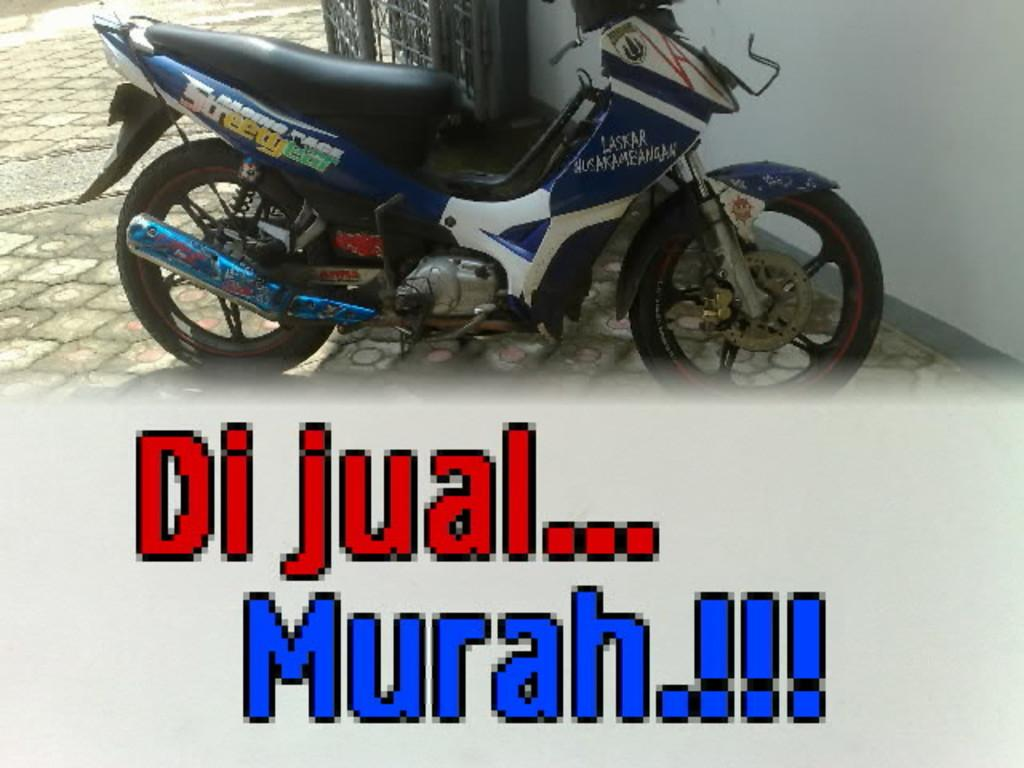What is the main object in the image? There is a bike in the image. Where is the bike located? The bike is on the floor. What can be seen near the bike? There are gates beside the bike. What type of badge is attached to the bike in the image? There is no badge attached to the bike in the image. Can you see a toad sitting on the bike in the image? There is no toad present in the image. 